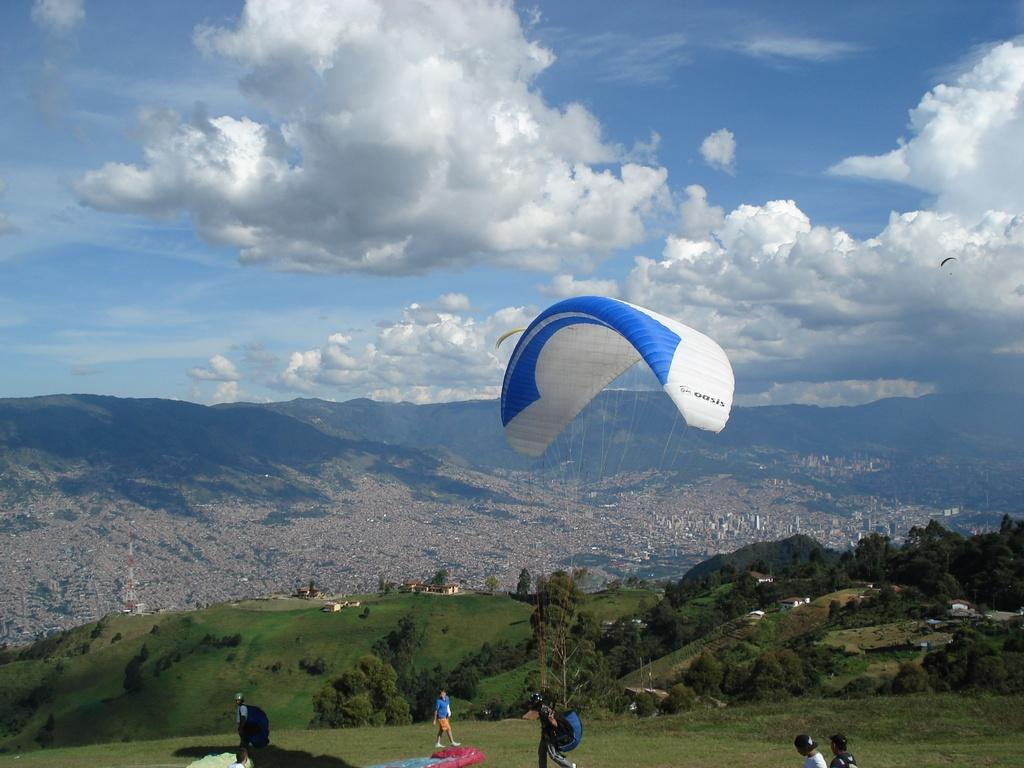What is the main subject of the image? The main subject of the image is a paraglider. Are there any other people in the image besides the paraglider? Yes, there are people in the image. What type of terrain is visible in the image? There is grass and a hill visible in the image. What can be seen in the sky in the image? Clouds are visible in the sky in the image. What sign can be seen in the image, indicating the direction to the nearest hearing aid store? There is no sign present in the image, nor is there any indication of a hearing aid store. 